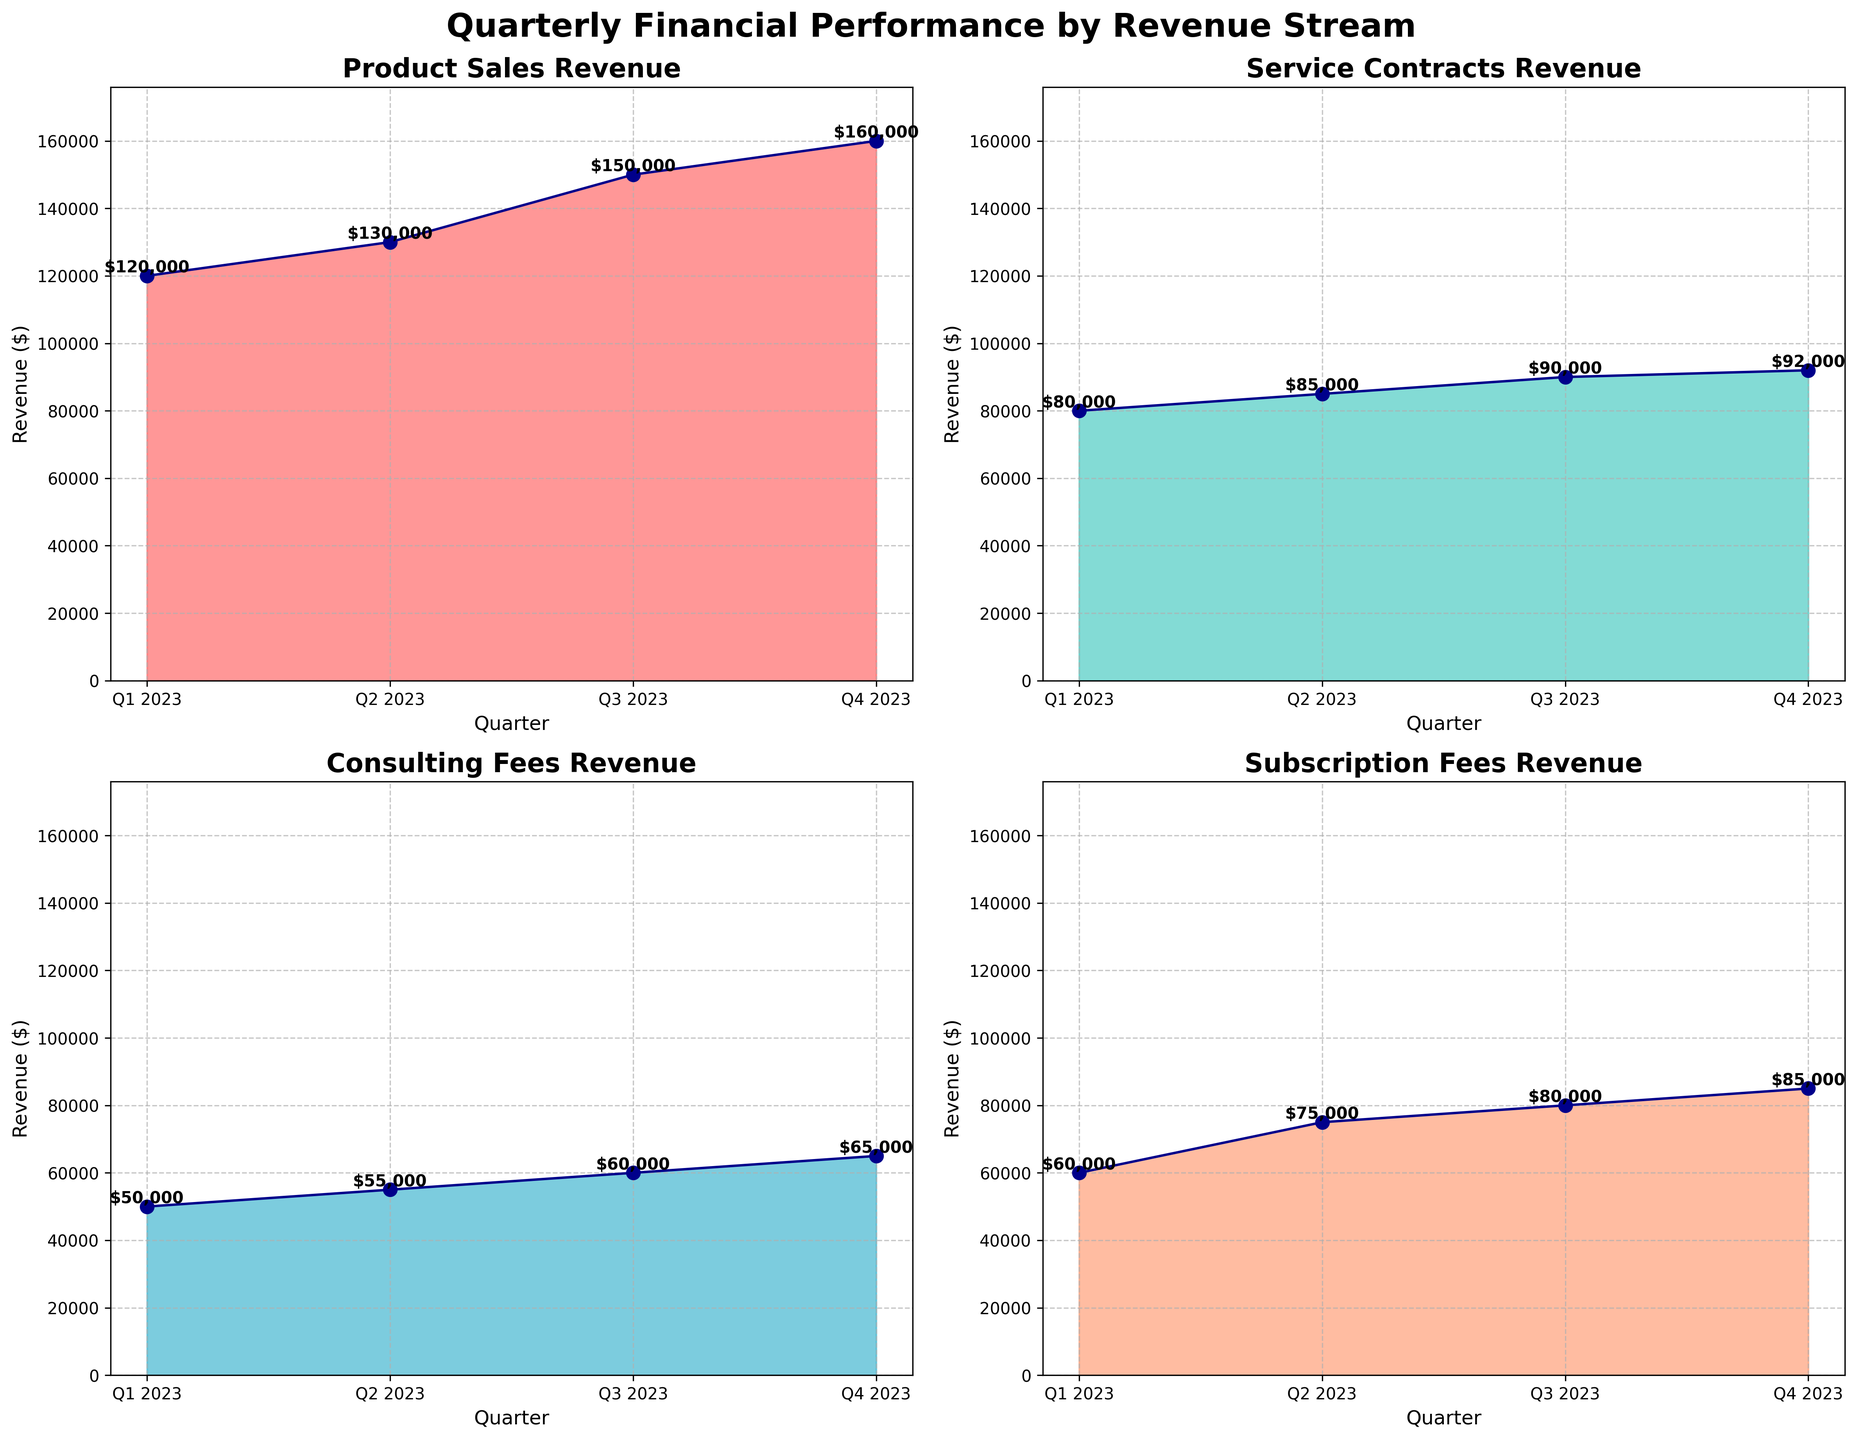What is the title of the overall figure? The title is located at the top center of the figure. It reads "Quarterly Financial Performance by Revenue Stream".
Answer: Quarterly Financial Performance by Revenue Stream Which revenue stream saw the highest revenue in Q4 2023? By looking at the Q4 2023 area for each subplot, the revenue stream with the tallest area is "Product Sales".
Answer: Product Sales What is the lowest revenue in Q1 2023 and which revenue stream does it belong to? By examining the values at Q1 2023 in each subplot, the lowest revenue is $50,000 in the "Consulting Fees" revenue stream.
Answer: $50,000 (Consulting Fees) What is the sum of revenues from all streams in Q2 2023? Add the revenues from each revenue stream in Q2 2023: $130,000 + $85,000 + $55,000 + $75,000 = $345,000.
Answer: $345,000 Which revenue stream showed the most growth from Q1 2023 to Q4 2023? Calculate the difference in revenues for each stream between Q1 2023 and Q4 2023. 
Product Sales: $160,000 - $120,000 = $40,000 
Service Contracts: $92,000 - $80,000 = $12,000 
Consulting Fees: $65,000 - $50,000 = $15,000 
Subscription Fees: $85,000 - $60,000 = $25,000 
The stream with the highest growth is "Product Sales".
Answer: Product Sales In which quarter did "Subscription Fees" generate the highest revenue? Check the "Subscription Fees" subplot and find the quarter with the highest area. The maximum value is $85,000 in Q4 2023.
Answer: Q4 2023 What is the average revenue of "Service Contracts" over the four quarters? Sum the revenues of "Service Contracts" and divide by the number of quarters: ($80,000 + $85,000 + $90,000 + $92,000) / 4 = $86,750.
Answer: $86,750 Which quarter saw the highest total revenue across all streams? Calculate the total revenue for each quarter:
Q1 2023: $120,000 + $80,000 + $50,000 + $60,000 = $310,000 
Q2 2023: $130,000 + $85,000 + $55,000 + $75,000 = $345,000 
Q3 2023: $150,000 + $90,000 + $60,000 + $80,000 = $380,000 
Q4 2023: $160,000 + $92,000 + $65,000 + $85,000 = $402,000 
The highest total revenue was in Q4 2023.
Answer: Q4 2023 